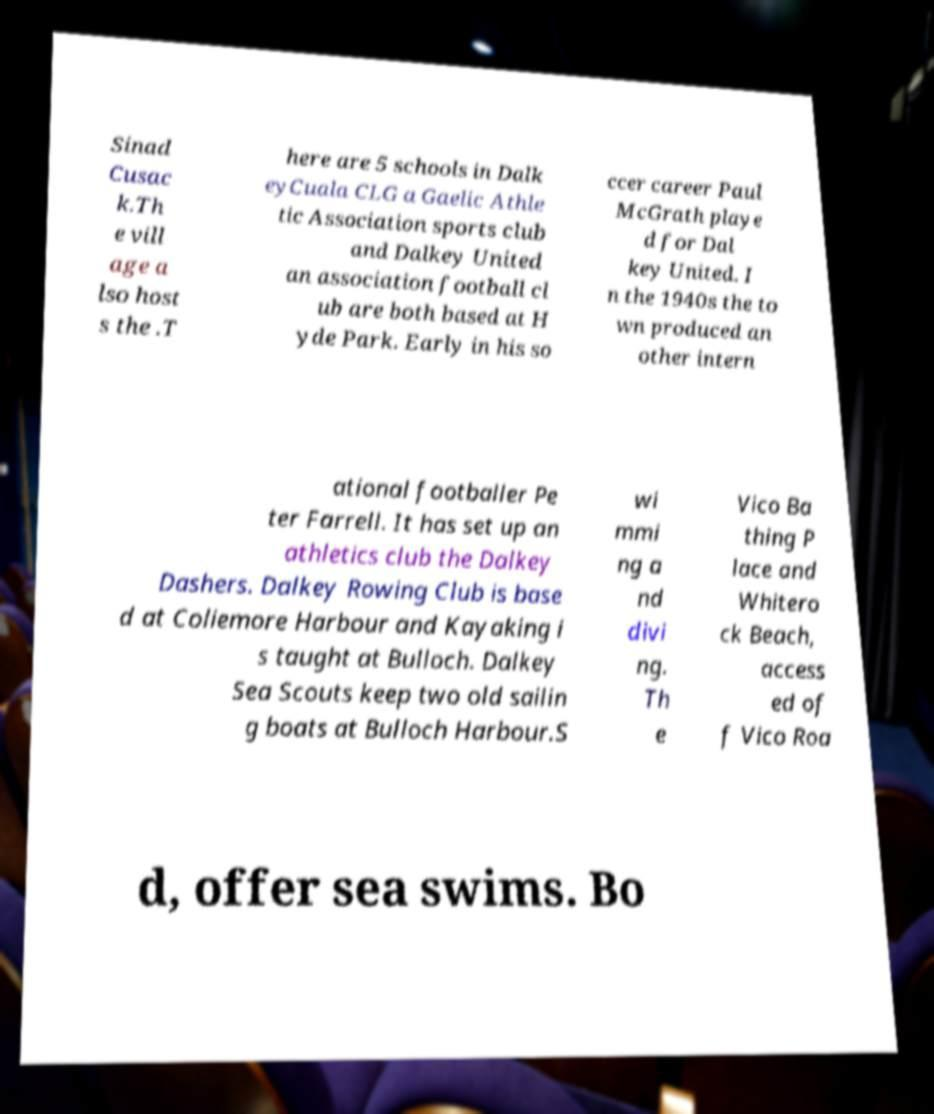Please identify and transcribe the text found in this image. Sinad Cusac k.Th e vill age a lso host s the .T here are 5 schools in Dalk eyCuala CLG a Gaelic Athle tic Association sports club and Dalkey United an association football cl ub are both based at H yde Park. Early in his so ccer career Paul McGrath playe d for Dal key United. I n the 1940s the to wn produced an other intern ational footballer Pe ter Farrell. It has set up an athletics club the Dalkey Dashers. Dalkey Rowing Club is base d at Coliemore Harbour and Kayaking i s taught at Bulloch. Dalkey Sea Scouts keep two old sailin g boats at Bulloch Harbour.S wi mmi ng a nd divi ng. Th e Vico Ba thing P lace and Whitero ck Beach, access ed of f Vico Roa d, offer sea swims. Bo 